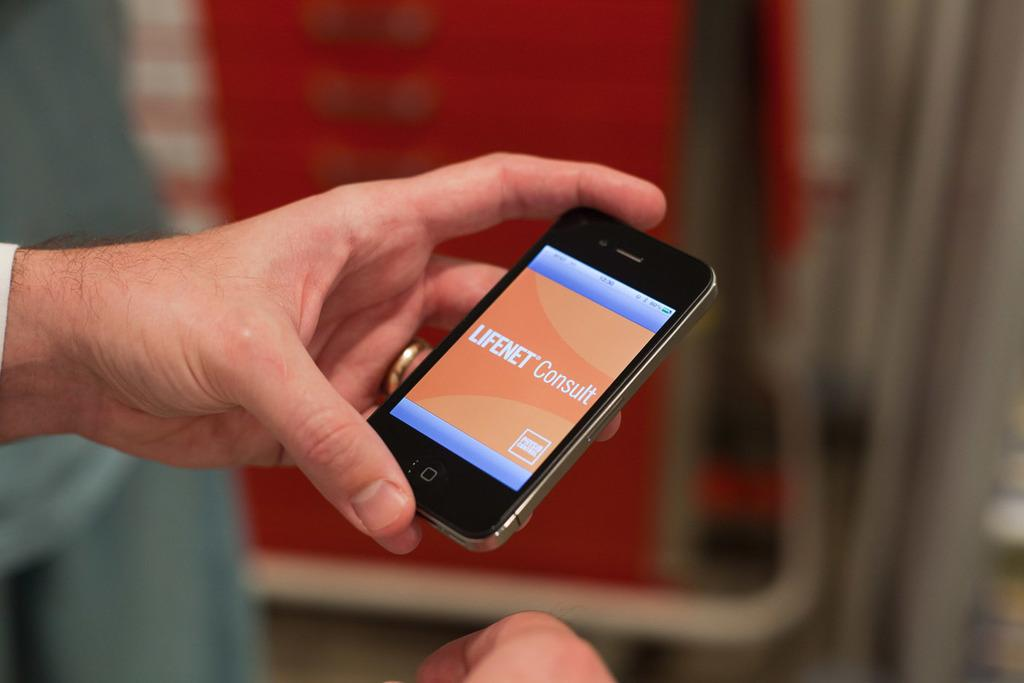Provide a one-sentence caption for the provided image. An iPhone connected to the internet displays the message LIFENET Consult. 